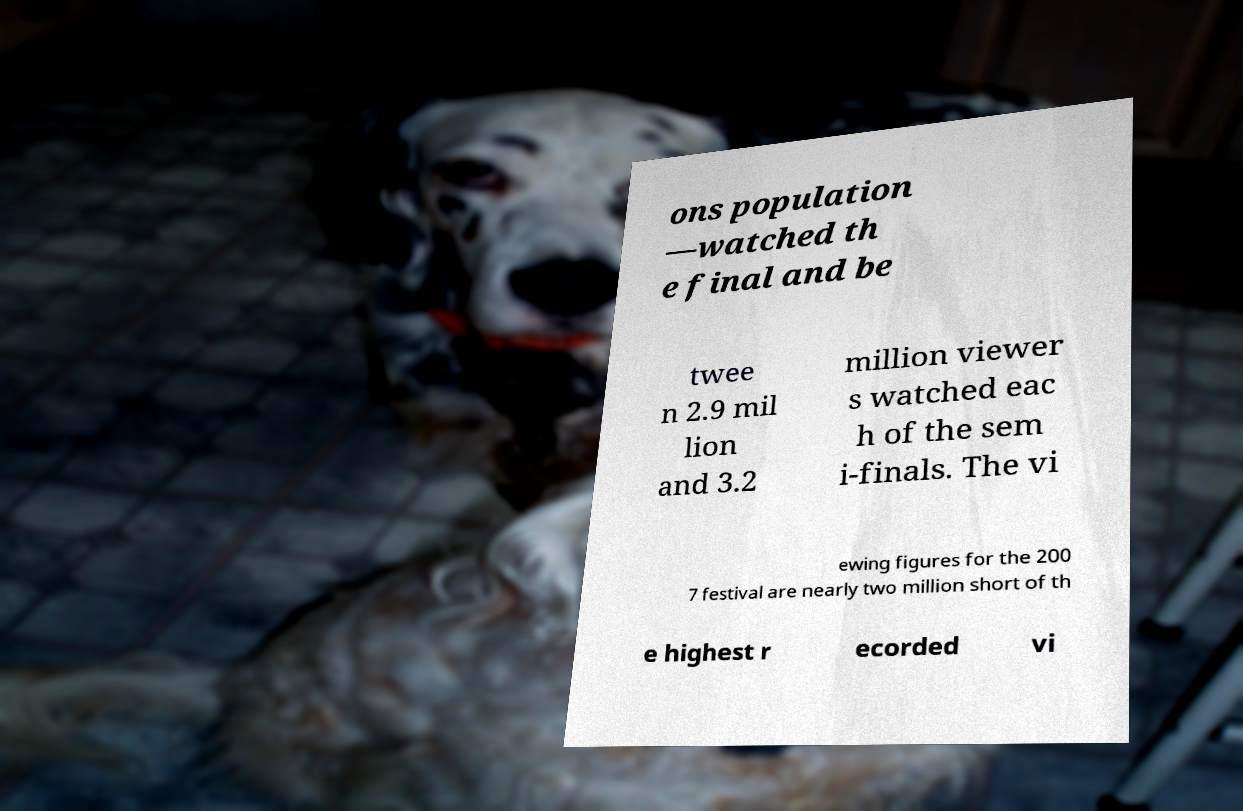What messages or text are displayed in this image? I need them in a readable, typed format. ons population —watched th e final and be twee n 2.9 mil lion and 3.2 million viewer s watched eac h of the sem i-finals. The vi ewing figures for the 200 7 festival are nearly two million short of th e highest r ecorded vi 